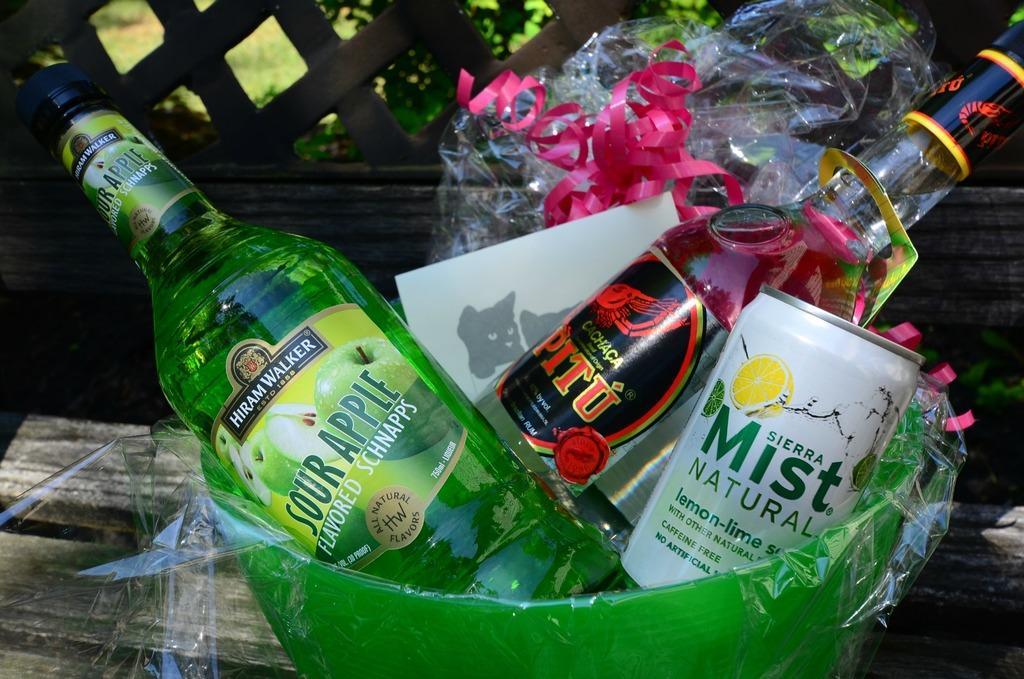Describe this image in one or two sentences. In this image, few bottles and tin are placed in the basket. We can see cover, ribbon and table. The background, few plants, grass. 